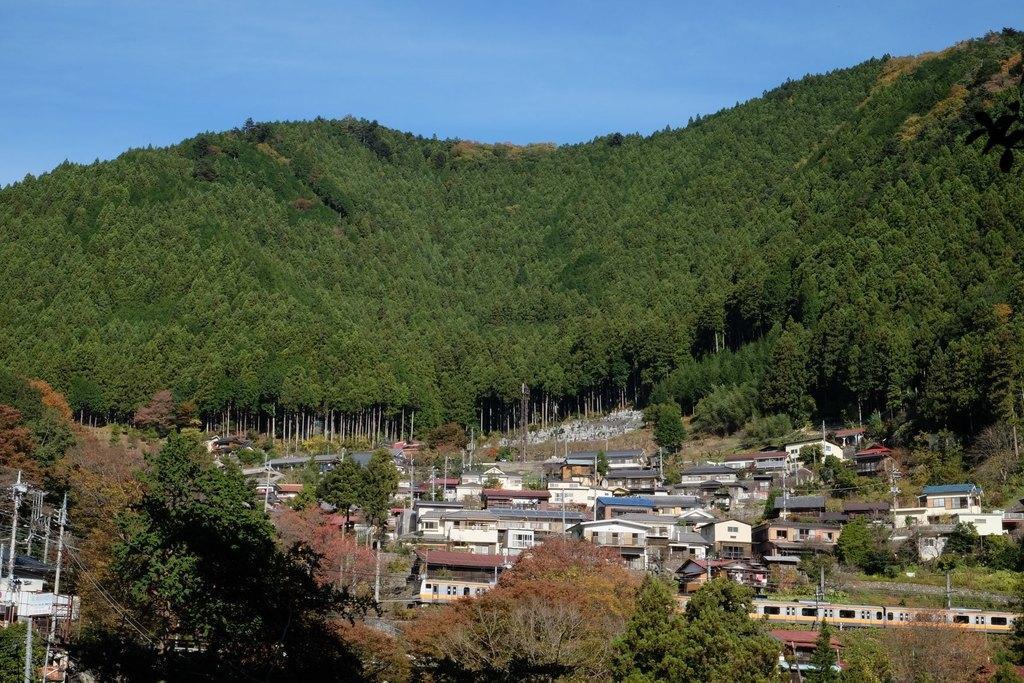Please provide a concise description of this image. In this image I can see buildings. There are trees, hills, poles, cables and in the background there is sky. 